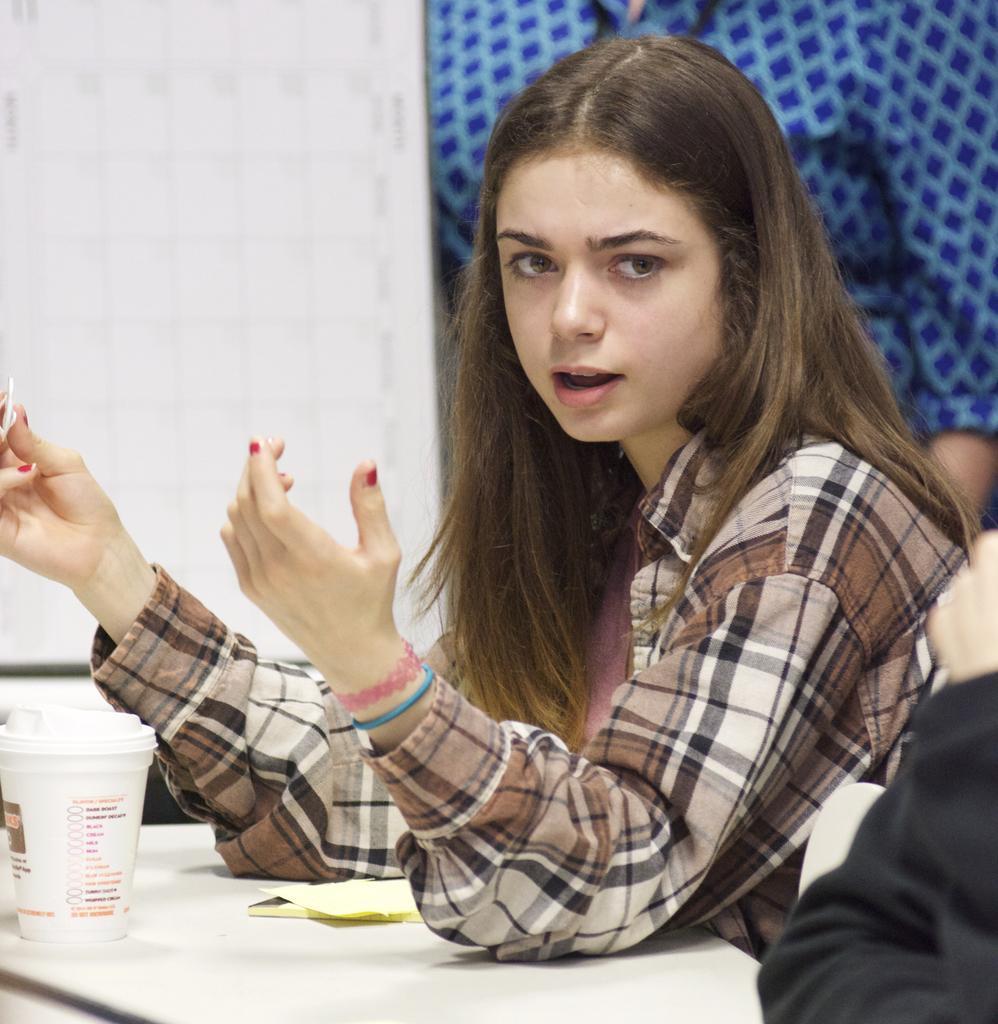In one or two sentences, can you explain what this image depicts? On the right side, there is a woman sitting, speaking and placing both elbows on a white color table, on which there is a cup. Beside her, there is a person. In the background, there is a person in a shirt and there is a white wall. 